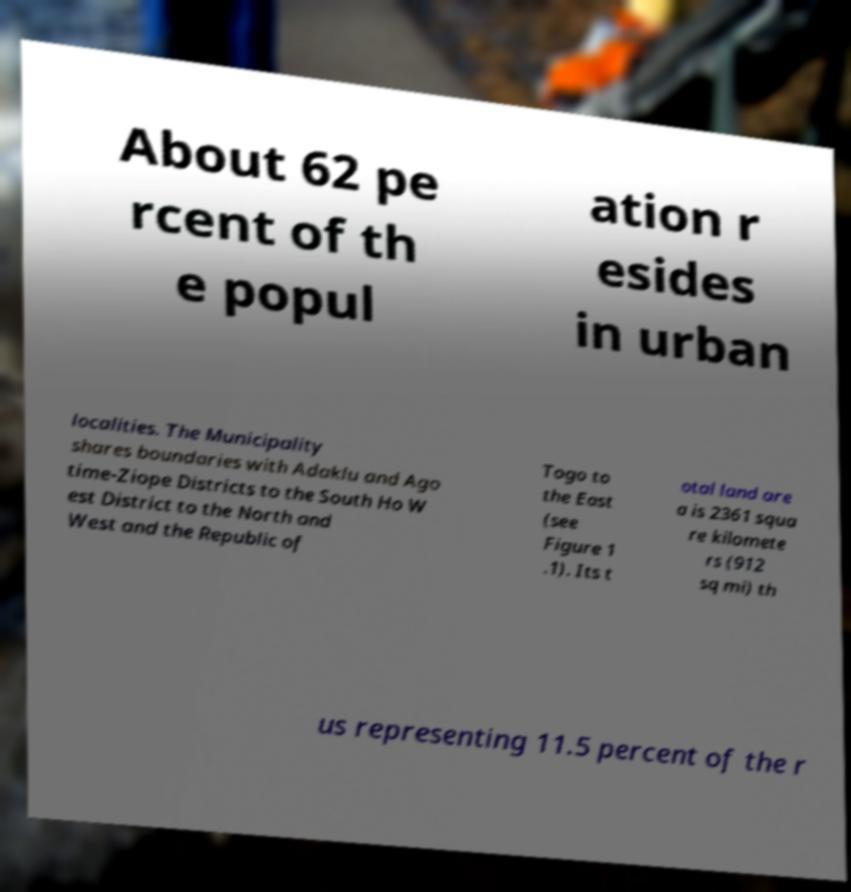Please identify and transcribe the text found in this image. About 62 pe rcent of th e popul ation r esides in urban localities. The Municipality shares boundaries with Adaklu and Ago time-Ziope Districts to the South Ho W est District to the North and West and the Republic of Togo to the East (see Figure 1 .1). Its t otal land are a is 2361 squa re kilomete rs (912 sq mi) th us representing 11.5 percent of the r 